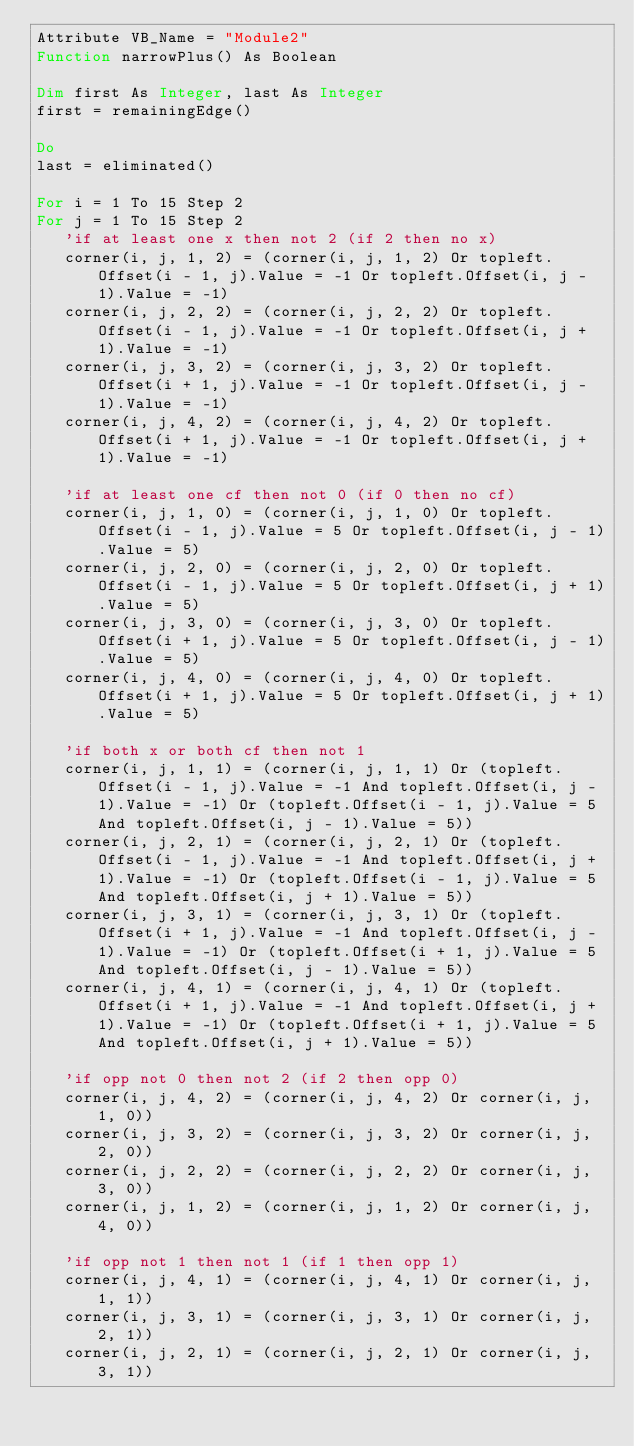Convert code to text. <code><loc_0><loc_0><loc_500><loc_500><_VisualBasic_>Attribute VB_Name = "Module2"
Function narrowPlus() As Boolean

Dim first As Integer, last As Integer
first = remainingEdge()

Do
last = eliminated()

For i = 1 To 15 Step 2
For j = 1 To 15 Step 2
   'if at least one x then not 2 (if 2 then no x)
   corner(i, j, 1, 2) = (corner(i, j, 1, 2) Or topleft.Offset(i - 1, j).Value = -1 Or topleft.Offset(i, j - 1).Value = -1)
   corner(i, j, 2, 2) = (corner(i, j, 2, 2) Or topleft.Offset(i - 1, j).Value = -1 Or topleft.Offset(i, j + 1).Value = -1)
   corner(i, j, 3, 2) = (corner(i, j, 3, 2) Or topleft.Offset(i + 1, j).Value = -1 Or topleft.Offset(i, j - 1).Value = -1)
   corner(i, j, 4, 2) = (corner(i, j, 4, 2) Or topleft.Offset(i + 1, j).Value = -1 Or topleft.Offset(i, j + 1).Value = -1)
   
   'if at least one cf then not 0 (if 0 then no cf)
   corner(i, j, 1, 0) = (corner(i, j, 1, 0) Or topleft.Offset(i - 1, j).Value = 5 Or topleft.Offset(i, j - 1).Value = 5)
   corner(i, j, 2, 0) = (corner(i, j, 2, 0) Or topleft.Offset(i - 1, j).Value = 5 Or topleft.Offset(i, j + 1).Value = 5)
   corner(i, j, 3, 0) = (corner(i, j, 3, 0) Or topleft.Offset(i + 1, j).Value = 5 Or topleft.Offset(i, j - 1).Value = 5)
   corner(i, j, 4, 0) = (corner(i, j, 4, 0) Or topleft.Offset(i + 1, j).Value = 5 Or topleft.Offset(i, j + 1).Value = 5)
   
   'if both x or both cf then not 1
   corner(i, j, 1, 1) = (corner(i, j, 1, 1) Or (topleft.Offset(i - 1, j).Value = -1 And topleft.Offset(i, j - 1).Value = -1) Or (topleft.Offset(i - 1, j).Value = 5 And topleft.Offset(i, j - 1).Value = 5))
   corner(i, j, 2, 1) = (corner(i, j, 2, 1) Or (topleft.Offset(i - 1, j).Value = -1 And topleft.Offset(i, j + 1).Value = -1) Or (topleft.Offset(i - 1, j).Value = 5 And topleft.Offset(i, j + 1).Value = 5))
   corner(i, j, 3, 1) = (corner(i, j, 3, 1) Or (topleft.Offset(i + 1, j).Value = -1 And topleft.Offset(i, j - 1).Value = -1) Or (topleft.Offset(i + 1, j).Value = 5 And topleft.Offset(i, j - 1).Value = 5))
   corner(i, j, 4, 1) = (corner(i, j, 4, 1) Or (topleft.Offset(i + 1, j).Value = -1 And topleft.Offset(i, j + 1).Value = -1) Or (topleft.Offset(i + 1, j).Value = 5 And topleft.Offset(i, j + 1).Value = 5))
   
   'if opp not 0 then not 2 (if 2 then opp 0)
   corner(i, j, 4, 2) = (corner(i, j, 4, 2) Or corner(i, j, 1, 0))
   corner(i, j, 3, 2) = (corner(i, j, 3, 2) Or corner(i, j, 2, 0))
   corner(i, j, 2, 2) = (corner(i, j, 2, 2) Or corner(i, j, 3, 0))
   corner(i, j, 1, 2) = (corner(i, j, 1, 2) Or corner(i, j, 4, 0))
   
   'if opp not 1 then not 1 (if 1 then opp 1)
   corner(i, j, 4, 1) = (corner(i, j, 4, 1) Or corner(i, j, 1, 1))
   corner(i, j, 3, 1) = (corner(i, j, 3, 1) Or corner(i, j, 2, 1))
   corner(i, j, 2, 1) = (corner(i, j, 2, 1) Or corner(i, j, 3, 1))</code> 